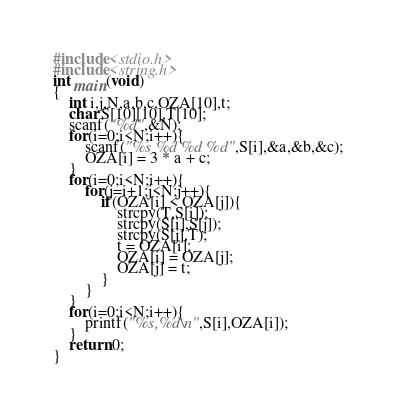Convert code to text. <code><loc_0><loc_0><loc_500><loc_500><_C_>#include<stdio.h>
#include<string.h>
int main(void)
{
	int i,j,N,a,b,c,OZA[10],t;
	char S[10][10],T[10];
	scanf("%d",&N);
	for(i=0;i<N;i++){
		scanf("%s %d %d %d",S[i],&a,&b,&c);
		OZA[i] = 3 * a + c;
	}
	for(i=0;i<N;i++){
		for(j=i+1;j<N;j++){
			if(OZA[i] < OZA[j]){
				strcpy(T,S[i]);
				strcpy(S[i],S[j]);
				strcpy(S[j],T);
				t = OZA[i];
				OZA[i] = OZA[j];
				OZA[j] = t;
			}
		}
	}
	for(i=0;i<N;i++){
		printf("%s,%d\n",S[i],OZA[i]);
	}
	return 0;
}</code> 